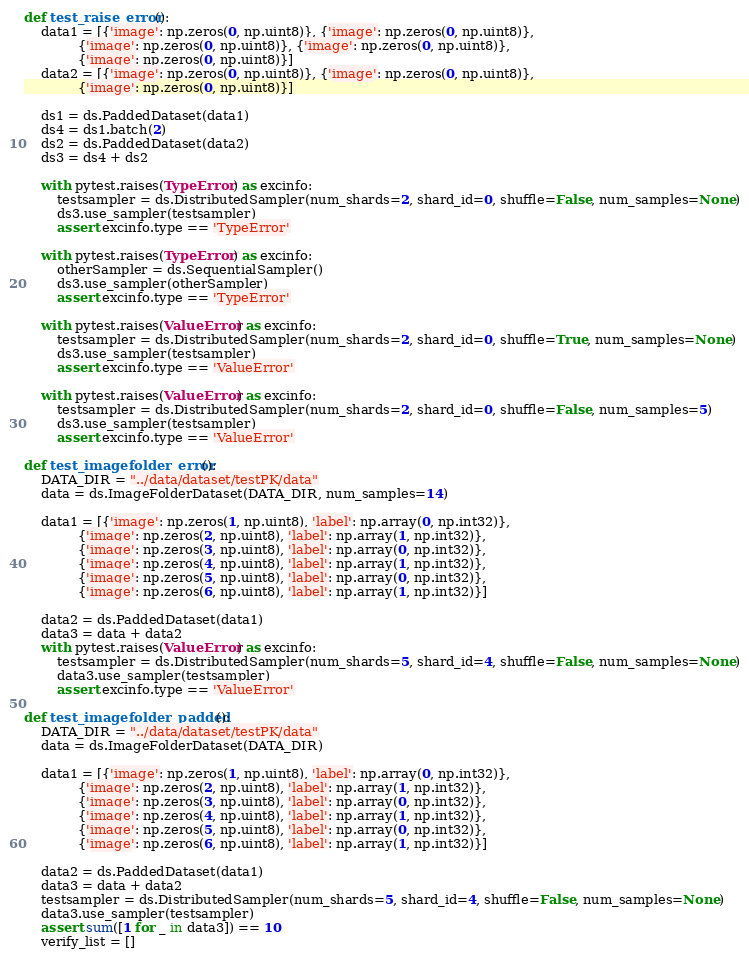Convert code to text. <code><loc_0><loc_0><loc_500><loc_500><_Python_>

def test_raise_error():
    data1 = [{'image': np.zeros(0, np.uint8)}, {'image': np.zeros(0, np.uint8)},
             {'image': np.zeros(0, np.uint8)}, {'image': np.zeros(0, np.uint8)},
             {'image': np.zeros(0, np.uint8)}]
    data2 = [{'image': np.zeros(0, np.uint8)}, {'image': np.zeros(0, np.uint8)},
             {'image': np.zeros(0, np.uint8)}]

    ds1 = ds.PaddedDataset(data1)
    ds4 = ds1.batch(2)
    ds2 = ds.PaddedDataset(data2)
    ds3 = ds4 + ds2

    with pytest.raises(TypeError) as excinfo:
        testsampler = ds.DistributedSampler(num_shards=2, shard_id=0, shuffle=False, num_samples=None)
        ds3.use_sampler(testsampler)
        assert excinfo.type == 'TypeError'

    with pytest.raises(TypeError) as excinfo:
        otherSampler = ds.SequentialSampler()
        ds3.use_sampler(otherSampler)
        assert excinfo.type == 'TypeError'

    with pytest.raises(ValueError) as excinfo:
        testsampler = ds.DistributedSampler(num_shards=2, shard_id=0, shuffle=True, num_samples=None)
        ds3.use_sampler(testsampler)
        assert excinfo.type == 'ValueError'

    with pytest.raises(ValueError) as excinfo:
        testsampler = ds.DistributedSampler(num_shards=2, shard_id=0, shuffle=False, num_samples=5)
        ds3.use_sampler(testsampler)
        assert excinfo.type == 'ValueError'

def test_imagefolder_error():
    DATA_DIR = "../data/dataset/testPK/data"
    data = ds.ImageFolderDataset(DATA_DIR, num_samples=14)

    data1 = [{'image': np.zeros(1, np.uint8), 'label': np.array(0, np.int32)},
             {'image': np.zeros(2, np.uint8), 'label': np.array(1, np.int32)},
             {'image': np.zeros(3, np.uint8), 'label': np.array(0, np.int32)},
             {'image': np.zeros(4, np.uint8), 'label': np.array(1, np.int32)},
             {'image': np.zeros(5, np.uint8), 'label': np.array(0, np.int32)},
             {'image': np.zeros(6, np.uint8), 'label': np.array(1, np.int32)}]

    data2 = ds.PaddedDataset(data1)
    data3 = data + data2
    with pytest.raises(ValueError) as excinfo:
        testsampler = ds.DistributedSampler(num_shards=5, shard_id=4, shuffle=False, num_samples=None)
        data3.use_sampler(testsampler)
        assert excinfo.type == 'ValueError'

def test_imagefolder_padded():
    DATA_DIR = "../data/dataset/testPK/data"
    data = ds.ImageFolderDataset(DATA_DIR)

    data1 = [{'image': np.zeros(1, np.uint8), 'label': np.array(0, np.int32)},
             {'image': np.zeros(2, np.uint8), 'label': np.array(1, np.int32)},
             {'image': np.zeros(3, np.uint8), 'label': np.array(0, np.int32)},
             {'image': np.zeros(4, np.uint8), 'label': np.array(1, np.int32)},
             {'image': np.zeros(5, np.uint8), 'label': np.array(0, np.int32)},
             {'image': np.zeros(6, np.uint8), 'label': np.array(1, np.int32)}]

    data2 = ds.PaddedDataset(data1)
    data3 = data + data2
    testsampler = ds.DistributedSampler(num_shards=5, shard_id=4, shuffle=False, num_samples=None)
    data3.use_sampler(testsampler)
    assert sum([1 for _ in data3]) == 10
    verify_list = []
</code> 